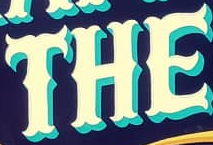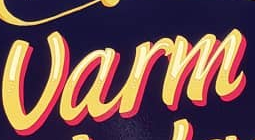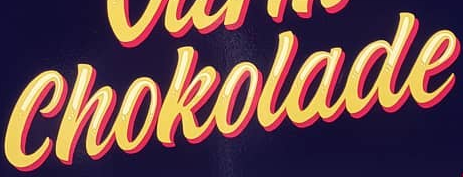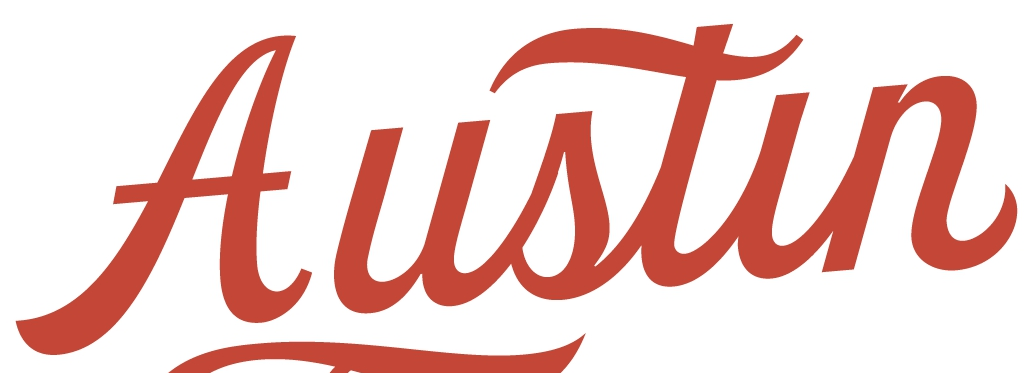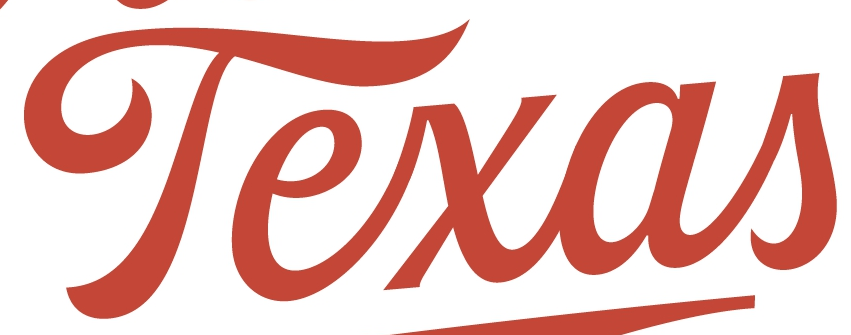What text appears in these images from left to right, separated by a semicolon? THE; Varm; Chokolade; Austin; Texas 